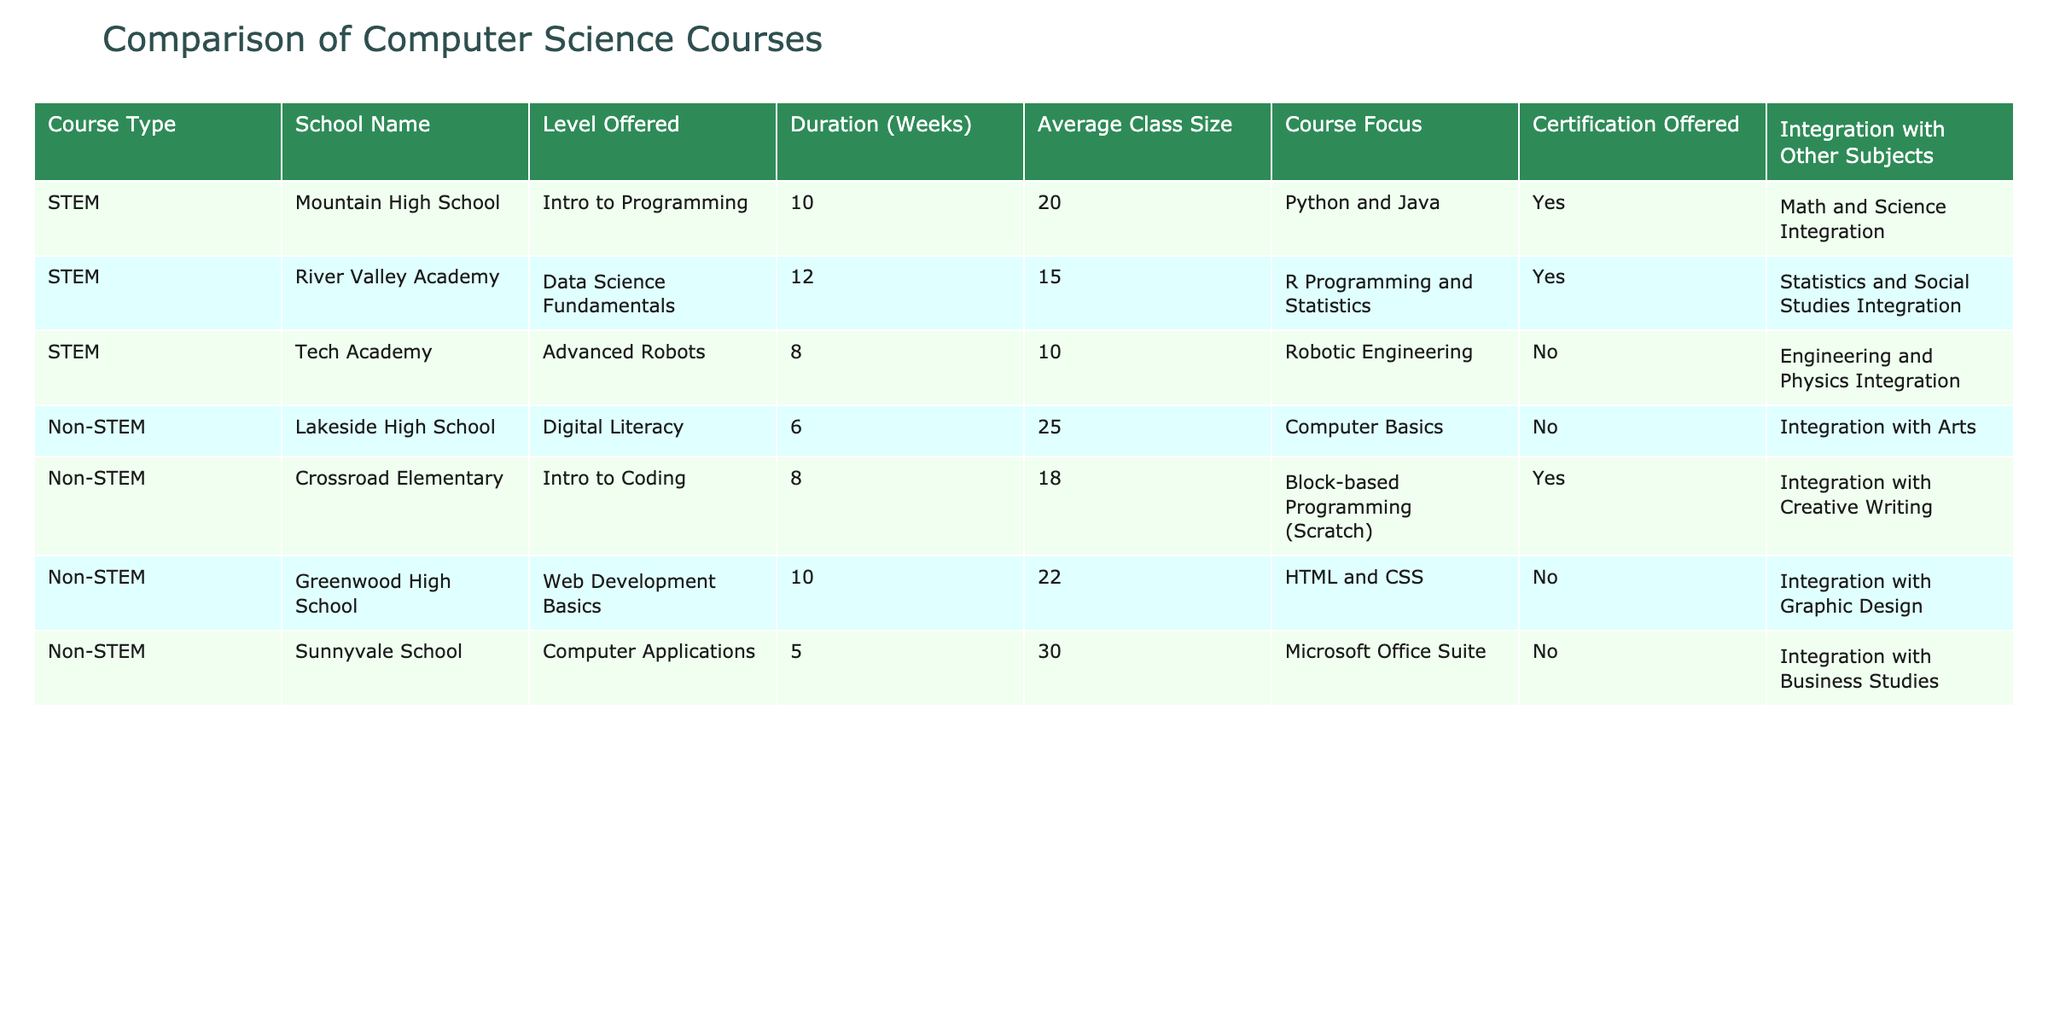What is the average class size for STEM courses? The STEM courses listed are from Mountain High School (20), River Valley Academy (15), and Tech Academy (10). To find the average, we add these values: 20 + 15 + 10 = 45. Then, we divide by the number of courses, which is 3: 45 / 3 = 15.
Answer: 15 How many weeks is the duration of the course offered at Sunnyvale School? From the table, it shows the duration of courses at Sunnyvale School is 5 weeks.
Answer: 5 weeks Are certifications offered in the Robotics course at Tech Academy? The table indicates that Tech Academy does not offer certifications for its Advanced Robots course, so the answer is no.
Answer: No What is the focus of the course offered at Lakeside High School? According to the table, the focus of the Digital Literacy course at Lakeside High School is on Computer Basics.
Answer: Computer Basics Which school offers the longest course duration, and how long is it? The longest course duration is at River Valley Academy, offering Data Science Fundamentals for 12 weeks. To confirm, we look through the durations for each course, and River Valley Academy stands out with the value of 12 weeks.
Answer: River Valley Academy, 12 weeks What proportion of the courses offered in Non-STEM schools integrate with other subjects? There are four courses listed for Non-STEM schools: Digital Literacy, Intro to Coding, Web Development Basics, and Computer Applications. Out of these, Intro to Coding is the only course that offers integration with other subjects (Creative Writing). Thus, the proportion is 1 integrate course out of 4 total courses, giving a proportion of 1/4 or 25%.
Answer: 25% Which computer science course has the largest average class size, and what is that size? The courses are analyzed based on their average class sizes: Lakeside High School (25), Crossroad Elementary (18), Greenwood High School (22), and Sunnyvale School (30). The largest average class size is at Sunnyvale School with 30 students.
Answer: Sunnyvale School, 30 Is Data Science Fundamentals offered at a STEM or Non-STEM school? The table states that Data Science Fundamentals is offered at River Valley Academy, which is categorized under STEM schools.
Answer: STEM What percentage of STEM courses offer integration with other subjects? There are three STEM courses. Mountain High School and River Valley Academy both offer integration (2 courses), while Tech Academy does not (1 course). The percentage calculation is (2 integration courses / 3 total courses) * 100 = 66.67%.
Answer: 66.67% 